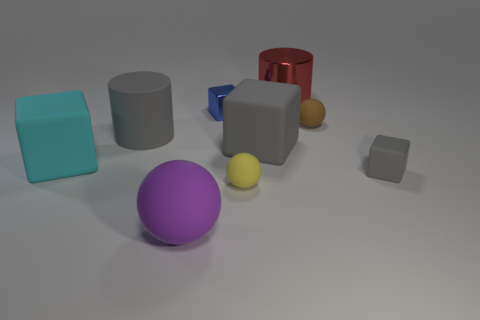Subtract all large gray rubber cubes. How many cubes are left? 3 Subtract 2 blocks. How many blocks are left? 2 Subtract all blue cubes. How many cubes are left? 3 Subtract all yellow cubes. Subtract all red cylinders. How many cubes are left? 4 Add 1 yellow matte cylinders. How many objects exist? 10 Subtract all cylinders. How many objects are left? 7 Subtract all large metallic cubes. Subtract all big gray blocks. How many objects are left? 8 Add 1 tiny spheres. How many tiny spheres are left? 3 Add 6 tiny brown matte objects. How many tiny brown matte objects exist? 7 Subtract 0 green cylinders. How many objects are left? 9 